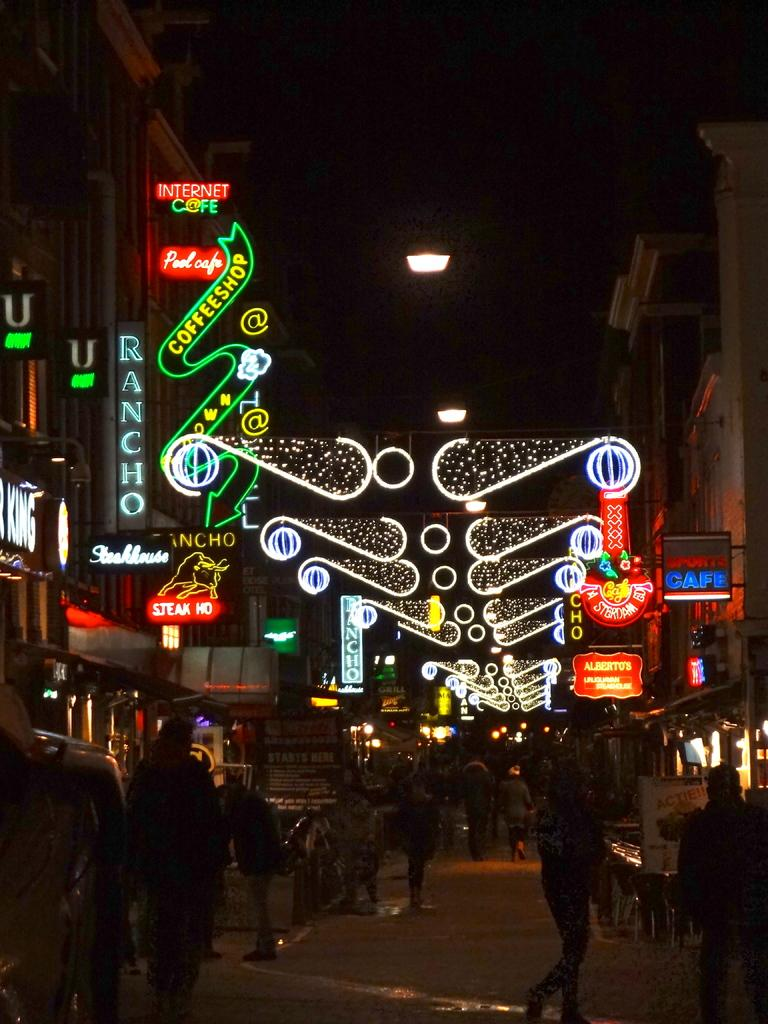What is happening on the road in the image? There are people on the road in the image. What can be seen on the left side of the image? There are buildings on the left side of the image. What can be seen on the right side of the image? There are buildings on the right side of the image. What is written on the buildings in the image? There is text written on the buildings. What is present at the top of the buildings in the image? There are lights at the top of the buildings. Where are the rabbits hiding in the image? There are no rabbits present in the image. What type of books can be seen on the buildings in the image? There are no books visible in the image; only text and lights are present on the buildings. 